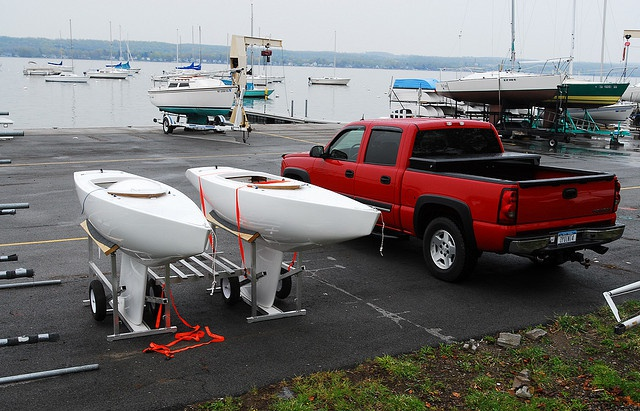Describe the objects in this image and their specific colors. I can see truck in lightgray, black, brown, maroon, and gray tones, boat in lightgray, darkgray, gray, and black tones, boat in lightgray, black, darkgray, and gray tones, boat in lightgray, white, darkgray, and gray tones, and boat in lightgray, darkgray, black, and gray tones in this image. 